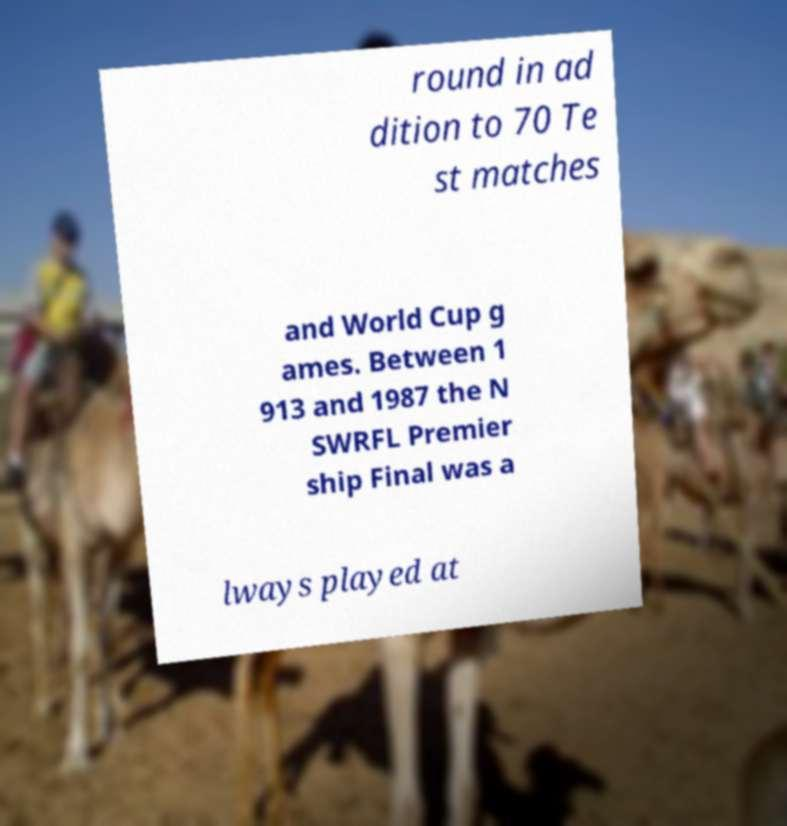Can you accurately transcribe the text from the provided image for me? round in ad dition to 70 Te st matches and World Cup g ames. Between 1 913 and 1987 the N SWRFL Premier ship Final was a lways played at 